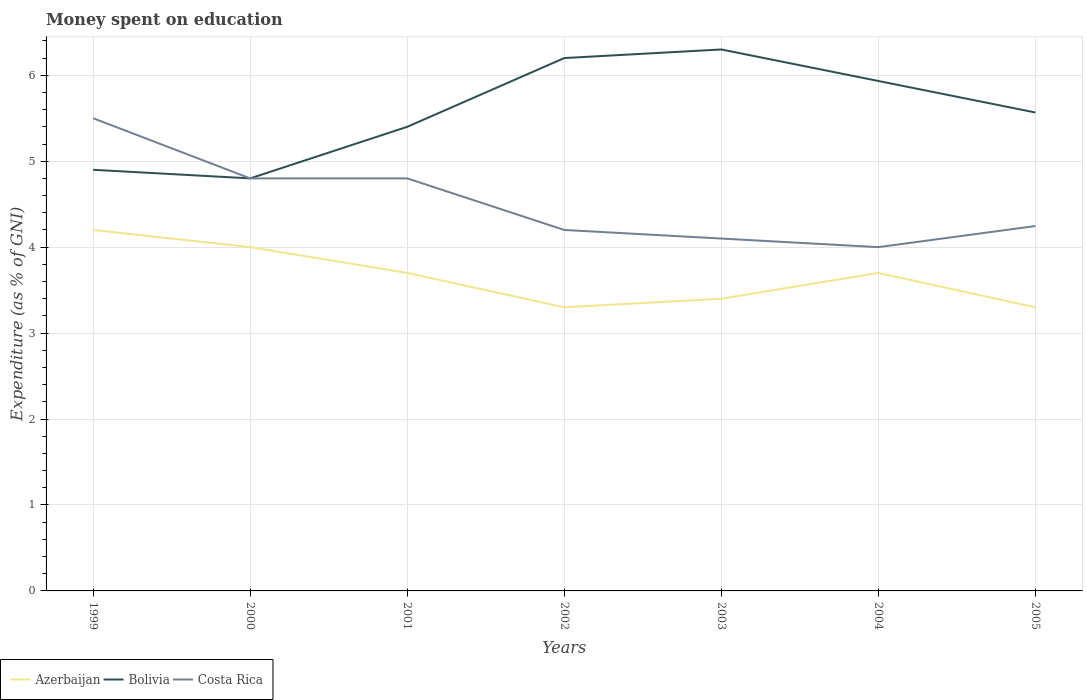How many different coloured lines are there?
Your answer should be very brief. 3. Across all years, what is the maximum amount of money spent on education in Costa Rica?
Offer a very short reply. 4. In which year was the amount of money spent on education in Azerbaijan maximum?
Offer a terse response. 2002. What is the total amount of money spent on education in Bolivia in the graph?
Your answer should be compact. 0.37. What is the difference between the highest and the second highest amount of money spent on education in Azerbaijan?
Make the answer very short. 0.9. Is the amount of money spent on education in Bolivia strictly greater than the amount of money spent on education in Azerbaijan over the years?
Ensure brevity in your answer.  No. How many lines are there?
Your response must be concise. 3. Are the values on the major ticks of Y-axis written in scientific E-notation?
Provide a short and direct response. No. How many legend labels are there?
Provide a succinct answer. 3. How are the legend labels stacked?
Ensure brevity in your answer.  Horizontal. What is the title of the graph?
Keep it short and to the point. Money spent on education. Does "Venezuela" appear as one of the legend labels in the graph?
Offer a terse response. No. What is the label or title of the Y-axis?
Offer a terse response. Expenditure (as % of GNI). What is the Expenditure (as % of GNI) in Azerbaijan in 1999?
Ensure brevity in your answer.  4.2. What is the Expenditure (as % of GNI) in Bolivia in 1999?
Give a very brief answer. 4.9. What is the Expenditure (as % of GNI) of Costa Rica in 1999?
Offer a terse response. 5.5. What is the Expenditure (as % of GNI) in Azerbaijan in 2000?
Your answer should be very brief. 4. What is the Expenditure (as % of GNI) in Bolivia in 2000?
Offer a terse response. 4.8. What is the Expenditure (as % of GNI) in Azerbaijan in 2001?
Your answer should be compact. 3.7. What is the Expenditure (as % of GNI) in Costa Rica in 2001?
Your answer should be compact. 4.8. What is the Expenditure (as % of GNI) in Azerbaijan in 2002?
Provide a short and direct response. 3.3. What is the Expenditure (as % of GNI) of Bolivia in 2002?
Make the answer very short. 6.2. What is the Expenditure (as % of GNI) of Costa Rica in 2002?
Your answer should be very brief. 4.2. What is the Expenditure (as % of GNI) of Bolivia in 2003?
Keep it short and to the point. 6.3. What is the Expenditure (as % of GNI) of Costa Rica in 2003?
Provide a short and direct response. 4.1. What is the Expenditure (as % of GNI) of Bolivia in 2004?
Your answer should be very brief. 5.93. What is the Expenditure (as % of GNI) of Costa Rica in 2004?
Ensure brevity in your answer.  4. What is the Expenditure (as % of GNI) of Azerbaijan in 2005?
Provide a short and direct response. 3.3. What is the Expenditure (as % of GNI) of Bolivia in 2005?
Ensure brevity in your answer.  5.57. What is the Expenditure (as % of GNI) of Costa Rica in 2005?
Ensure brevity in your answer.  4.25. Across all years, what is the minimum Expenditure (as % of GNI) of Bolivia?
Offer a very short reply. 4.8. What is the total Expenditure (as % of GNI) of Azerbaijan in the graph?
Keep it short and to the point. 25.6. What is the total Expenditure (as % of GNI) of Bolivia in the graph?
Ensure brevity in your answer.  39.1. What is the total Expenditure (as % of GNI) in Costa Rica in the graph?
Keep it short and to the point. 31.65. What is the difference between the Expenditure (as % of GNI) in Azerbaijan in 1999 and that in 2001?
Keep it short and to the point. 0.5. What is the difference between the Expenditure (as % of GNI) in Bolivia in 1999 and that in 2001?
Your answer should be very brief. -0.5. What is the difference between the Expenditure (as % of GNI) in Costa Rica in 1999 and that in 2001?
Give a very brief answer. 0.7. What is the difference between the Expenditure (as % of GNI) in Costa Rica in 1999 and that in 2003?
Provide a short and direct response. 1.4. What is the difference between the Expenditure (as % of GNI) of Bolivia in 1999 and that in 2004?
Ensure brevity in your answer.  -1.03. What is the difference between the Expenditure (as % of GNI) in Azerbaijan in 1999 and that in 2005?
Your answer should be very brief. 0.9. What is the difference between the Expenditure (as % of GNI) in Costa Rica in 1999 and that in 2005?
Offer a terse response. 1.25. What is the difference between the Expenditure (as % of GNI) of Azerbaijan in 2000 and that in 2001?
Your answer should be very brief. 0.3. What is the difference between the Expenditure (as % of GNI) in Bolivia in 2000 and that in 2002?
Make the answer very short. -1.4. What is the difference between the Expenditure (as % of GNI) of Azerbaijan in 2000 and that in 2003?
Your response must be concise. 0.6. What is the difference between the Expenditure (as % of GNI) in Bolivia in 2000 and that in 2003?
Provide a succinct answer. -1.5. What is the difference between the Expenditure (as % of GNI) in Costa Rica in 2000 and that in 2003?
Make the answer very short. 0.7. What is the difference between the Expenditure (as % of GNI) of Azerbaijan in 2000 and that in 2004?
Offer a terse response. 0.3. What is the difference between the Expenditure (as % of GNI) in Bolivia in 2000 and that in 2004?
Offer a terse response. -1.13. What is the difference between the Expenditure (as % of GNI) of Costa Rica in 2000 and that in 2004?
Your answer should be very brief. 0.8. What is the difference between the Expenditure (as % of GNI) in Bolivia in 2000 and that in 2005?
Provide a short and direct response. -0.77. What is the difference between the Expenditure (as % of GNI) in Costa Rica in 2000 and that in 2005?
Your response must be concise. 0.55. What is the difference between the Expenditure (as % of GNI) in Bolivia in 2001 and that in 2002?
Keep it short and to the point. -0.8. What is the difference between the Expenditure (as % of GNI) of Costa Rica in 2001 and that in 2002?
Give a very brief answer. 0.6. What is the difference between the Expenditure (as % of GNI) in Azerbaijan in 2001 and that in 2003?
Give a very brief answer. 0.3. What is the difference between the Expenditure (as % of GNI) in Bolivia in 2001 and that in 2003?
Ensure brevity in your answer.  -0.9. What is the difference between the Expenditure (as % of GNI) in Azerbaijan in 2001 and that in 2004?
Offer a very short reply. 0. What is the difference between the Expenditure (as % of GNI) in Bolivia in 2001 and that in 2004?
Your answer should be compact. -0.53. What is the difference between the Expenditure (as % of GNI) in Costa Rica in 2001 and that in 2004?
Your answer should be compact. 0.8. What is the difference between the Expenditure (as % of GNI) in Bolivia in 2001 and that in 2005?
Provide a short and direct response. -0.17. What is the difference between the Expenditure (as % of GNI) of Costa Rica in 2001 and that in 2005?
Offer a very short reply. 0.55. What is the difference between the Expenditure (as % of GNI) of Bolivia in 2002 and that in 2003?
Provide a succinct answer. -0.1. What is the difference between the Expenditure (as % of GNI) of Azerbaijan in 2002 and that in 2004?
Your answer should be compact. -0.4. What is the difference between the Expenditure (as % of GNI) of Bolivia in 2002 and that in 2004?
Provide a short and direct response. 0.27. What is the difference between the Expenditure (as % of GNI) of Azerbaijan in 2002 and that in 2005?
Ensure brevity in your answer.  0. What is the difference between the Expenditure (as % of GNI) in Bolivia in 2002 and that in 2005?
Your answer should be very brief. 0.63. What is the difference between the Expenditure (as % of GNI) in Costa Rica in 2002 and that in 2005?
Give a very brief answer. -0.05. What is the difference between the Expenditure (as % of GNI) of Azerbaijan in 2003 and that in 2004?
Give a very brief answer. -0.3. What is the difference between the Expenditure (as % of GNI) of Bolivia in 2003 and that in 2004?
Offer a very short reply. 0.37. What is the difference between the Expenditure (as % of GNI) of Bolivia in 2003 and that in 2005?
Make the answer very short. 0.73. What is the difference between the Expenditure (as % of GNI) in Costa Rica in 2003 and that in 2005?
Make the answer very short. -0.15. What is the difference between the Expenditure (as % of GNI) in Azerbaijan in 2004 and that in 2005?
Offer a very short reply. 0.4. What is the difference between the Expenditure (as % of GNI) of Bolivia in 2004 and that in 2005?
Keep it short and to the point. 0.37. What is the difference between the Expenditure (as % of GNI) of Costa Rica in 2004 and that in 2005?
Offer a terse response. -0.25. What is the difference between the Expenditure (as % of GNI) of Azerbaijan in 1999 and the Expenditure (as % of GNI) of Bolivia in 2000?
Give a very brief answer. -0.6. What is the difference between the Expenditure (as % of GNI) in Azerbaijan in 1999 and the Expenditure (as % of GNI) in Costa Rica in 2000?
Your response must be concise. -0.6. What is the difference between the Expenditure (as % of GNI) in Azerbaijan in 1999 and the Expenditure (as % of GNI) in Bolivia in 2003?
Give a very brief answer. -2.1. What is the difference between the Expenditure (as % of GNI) in Azerbaijan in 1999 and the Expenditure (as % of GNI) in Costa Rica in 2003?
Provide a succinct answer. 0.1. What is the difference between the Expenditure (as % of GNI) of Azerbaijan in 1999 and the Expenditure (as % of GNI) of Bolivia in 2004?
Offer a terse response. -1.73. What is the difference between the Expenditure (as % of GNI) in Bolivia in 1999 and the Expenditure (as % of GNI) in Costa Rica in 2004?
Ensure brevity in your answer.  0.9. What is the difference between the Expenditure (as % of GNI) in Azerbaijan in 1999 and the Expenditure (as % of GNI) in Bolivia in 2005?
Offer a terse response. -1.37. What is the difference between the Expenditure (as % of GNI) in Azerbaijan in 1999 and the Expenditure (as % of GNI) in Costa Rica in 2005?
Make the answer very short. -0.05. What is the difference between the Expenditure (as % of GNI) of Bolivia in 1999 and the Expenditure (as % of GNI) of Costa Rica in 2005?
Your answer should be very brief. 0.65. What is the difference between the Expenditure (as % of GNI) of Bolivia in 2000 and the Expenditure (as % of GNI) of Costa Rica in 2001?
Provide a succinct answer. 0. What is the difference between the Expenditure (as % of GNI) of Azerbaijan in 2000 and the Expenditure (as % of GNI) of Costa Rica in 2002?
Your response must be concise. -0.2. What is the difference between the Expenditure (as % of GNI) of Bolivia in 2000 and the Expenditure (as % of GNI) of Costa Rica in 2002?
Ensure brevity in your answer.  0.6. What is the difference between the Expenditure (as % of GNI) of Azerbaijan in 2000 and the Expenditure (as % of GNI) of Costa Rica in 2003?
Keep it short and to the point. -0.1. What is the difference between the Expenditure (as % of GNI) in Bolivia in 2000 and the Expenditure (as % of GNI) in Costa Rica in 2003?
Offer a very short reply. 0.7. What is the difference between the Expenditure (as % of GNI) in Azerbaijan in 2000 and the Expenditure (as % of GNI) in Bolivia in 2004?
Provide a short and direct response. -1.93. What is the difference between the Expenditure (as % of GNI) in Azerbaijan in 2000 and the Expenditure (as % of GNI) in Costa Rica in 2004?
Make the answer very short. 0. What is the difference between the Expenditure (as % of GNI) in Azerbaijan in 2000 and the Expenditure (as % of GNI) in Bolivia in 2005?
Give a very brief answer. -1.57. What is the difference between the Expenditure (as % of GNI) in Azerbaijan in 2000 and the Expenditure (as % of GNI) in Costa Rica in 2005?
Your response must be concise. -0.25. What is the difference between the Expenditure (as % of GNI) of Bolivia in 2000 and the Expenditure (as % of GNI) of Costa Rica in 2005?
Keep it short and to the point. 0.55. What is the difference between the Expenditure (as % of GNI) of Azerbaijan in 2001 and the Expenditure (as % of GNI) of Bolivia in 2002?
Your answer should be compact. -2.5. What is the difference between the Expenditure (as % of GNI) of Azerbaijan in 2001 and the Expenditure (as % of GNI) of Bolivia in 2004?
Give a very brief answer. -2.23. What is the difference between the Expenditure (as % of GNI) in Bolivia in 2001 and the Expenditure (as % of GNI) in Costa Rica in 2004?
Provide a succinct answer. 1.4. What is the difference between the Expenditure (as % of GNI) in Azerbaijan in 2001 and the Expenditure (as % of GNI) in Bolivia in 2005?
Make the answer very short. -1.87. What is the difference between the Expenditure (as % of GNI) in Azerbaijan in 2001 and the Expenditure (as % of GNI) in Costa Rica in 2005?
Offer a very short reply. -0.55. What is the difference between the Expenditure (as % of GNI) of Bolivia in 2001 and the Expenditure (as % of GNI) of Costa Rica in 2005?
Provide a succinct answer. 1.15. What is the difference between the Expenditure (as % of GNI) of Azerbaijan in 2002 and the Expenditure (as % of GNI) of Costa Rica in 2003?
Offer a terse response. -0.8. What is the difference between the Expenditure (as % of GNI) of Bolivia in 2002 and the Expenditure (as % of GNI) of Costa Rica in 2003?
Offer a terse response. 2.1. What is the difference between the Expenditure (as % of GNI) of Azerbaijan in 2002 and the Expenditure (as % of GNI) of Bolivia in 2004?
Make the answer very short. -2.63. What is the difference between the Expenditure (as % of GNI) of Azerbaijan in 2002 and the Expenditure (as % of GNI) of Costa Rica in 2004?
Your response must be concise. -0.7. What is the difference between the Expenditure (as % of GNI) of Azerbaijan in 2002 and the Expenditure (as % of GNI) of Bolivia in 2005?
Provide a succinct answer. -2.27. What is the difference between the Expenditure (as % of GNI) of Azerbaijan in 2002 and the Expenditure (as % of GNI) of Costa Rica in 2005?
Offer a terse response. -0.95. What is the difference between the Expenditure (as % of GNI) of Bolivia in 2002 and the Expenditure (as % of GNI) of Costa Rica in 2005?
Offer a very short reply. 1.95. What is the difference between the Expenditure (as % of GNI) in Azerbaijan in 2003 and the Expenditure (as % of GNI) in Bolivia in 2004?
Provide a succinct answer. -2.53. What is the difference between the Expenditure (as % of GNI) in Bolivia in 2003 and the Expenditure (as % of GNI) in Costa Rica in 2004?
Keep it short and to the point. 2.3. What is the difference between the Expenditure (as % of GNI) in Azerbaijan in 2003 and the Expenditure (as % of GNI) in Bolivia in 2005?
Offer a very short reply. -2.17. What is the difference between the Expenditure (as % of GNI) of Azerbaijan in 2003 and the Expenditure (as % of GNI) of Costa Rica in 2005?
Provide a short and direct response. -0.85. What is the difference between the Expenditure (as % of GNI) in Bolivia in 2003 and the Expenditure (as % of GNI) in Costa Rica in 2005?
Keep it short and to the point. 2.05. What is the difference between the Expenditure (as % of GNI) of Azerbaijan in 2004 and the Expenditure (as % of GNI) of Bolivia in 2005?
Provide a succinct answer. -1.87. What is the difference between the Expenditure (as % of GNI) in Azerbaijan in 2004 and the Expenditure (as % of GNI) in Costa Rica in 2005?
Keep it short and to the point. -0.55. What is the difference between the Expenditure (as % of GNI) of Bolivia in 2004 and the Expenditure (as % of GNI) of Costa Rica in 2005?
Offer a very short reply. 1.69. What is the average Expenditure (as % of GNI) of Azerbaijan per year?
Your answer should be compact. 3.66. What is the average Expenditure (as % of GNI) of Bolivia per year?
Ensure brevity in your answer.  5.59. What is the average Expenditure (as % of GNI) of Costa Rica per year?
Offer a terse response. 4.52. In the year 1999, what is the difference between the Expenditure (as % of GNI) in Bolivia and Expenditure (as % of GNI) in Costa Rica?
Your answer should be compact. -0.6. In the year 2000, what is the difference between the Expenditure (as % of GNI) in Azerbaijan and Expenditure (as % of GNI) in Bolivia?
Provide a succinct answer. -0.8. In the year 2001, what is the difference between the Expenditure (as % of GNI) of Azerbaijan and Expenditure (as % of GNI) of Costa Rica?
Provide a short and direct response. -1.1. In the year 2001, what is the difference between the Expenditure (as % of GNI) in Bolivia and Expenditure (as % of GNI) in Costa Rica?
Your response must be concise. 0.6. In the year 2002, what is the difference between the Expenditure (as % of GNI) in Azerbaijan and Expenditure (as % of GNI) in Bolivia?
Offer a terse response. -2.9. In the year 2002, what is the difference between the Expenditure (as % of GNI) of Azerbaijan and Expenditure (as % of GNI) of Costa Rica?
Provide a succinct answer. -0.9. In the year 2002, what is the difference between the Expenditure (as % of GNI) of Bolivia and Expenditure (as % of GNI) of Costa Rica?
Offer a terse response. 2. In the year 2003, what is the difference between the Expenditure (as % of GNI) of Bolivia and Expenditure (as % of GNI) of Costa Rica?
Give a very brief answer. 2.2. In the year 2004, what is the difference between the Expenditure (as % of GNI) of Azerbaijan and Expenditure (as % of GNI) of Bolivia?
Make the answer very short. -2.23. In the year 2004, what is the difference between the Expenditure (as % of GNI) of Bolivia and Expenditure (as % of GNI) of Costa Rica?
Your answer should be very brief. 1.93. In the year 2005, what is the difference between the Expenditure (as % of GNI) in Azerbaijan and Expenditure (as % of GNI) in Bolivia?
Your answer should be very brief. -2.27. In the year 2005, what is the difference between the Expenditure (as % of GNI) in Azerbaijan and Expenditure (as % of GNI) in Costa Rica?
Offer a terse response. -0.95. In the year 2005, what is the difference between the Expenditure (as % of GNI) of Bolivia and Expenditure (as % of GNI) of Costa Rica?
Make the answer very short. 1.32. What is the ratio of the Expenditure (as % of GNI) in Azerbaijan in 1999 to that in 2000?
Provide a succinct answer. 1.05. What is the ratio of the Expenditure (as % of GNI) in Bolivia in 1999 to that in 2000?
Keep it short and to the point. 1.02. What is the ratio of the Expenditure (as % of GNI) in Costa Rica in 1999 to that in 2000?
Give a very brief answer. 1.15. What is the ratio of the Expenditure (as % of GNI) in Azerbaijan in 1999 to that in 2001?
Offer a terse response. 1.14. What is the ratio of the Expenditure (as % of GNI) of Bolivia in 1999 to that in 2001?
Your response must be concise. 0.91. What is the ratio of the Expenditure (as % of GNI) of Costa Rica in 1999 to that in 2001?
Provide a succinct answer. 1.15. What is the ratio of the Expenditure (as % of GNI) of Azerbaijan in 1999 to that in 2002?
Your response must be concise. 1.27. What is the ratio of the Expenditure (as % of GNI) of Bolivia in 1999 to that in 2002?
Provide a short and direct response. 0.79. What is the ratio of the Expenditure (as % of GNI) in Costa Rica in 1999 to that in 2002?
Offer a terse response. 1.31. What is the ratio of the Expenditure (as % of GNI) of Azerbaijan in 1999 to that in 2003?
Make the answer very short. 1.24. What is the ratio of the Expenditure (as % of GNI) in Bolivia in 1999 to that in 2003?
Your answer should be compact. 0.78. What is the ratio of the Expenditure (as % of GNI) in Costa Rica in 1999 to that in 2003?
Make the answer very short. 1.34. What is the ratio of the Expenditure (as % of GNI) in Azerbaijan in 1999 to that in 2004?
Keep it short and to the point. 1.14. What is the ratio of the Expenditure (as % of GNI) in Bolivia in 1999 to that in 2004?
Your answer should be compact. 0.83. What is the ratio of the Expenditure (as % of GNI) in Costa Rica in 1999 to that in 2004?
Your answer should be compact. 1.38. What is the ratio of the Expenditure (as % of GNI) in Azerbaijan in 1999 to that in 2005?
Offer a very short reply. 1.27. What is the ratio of the Expenditure (as % of GNI) in Bolivia in 1999 to that in 2005?
Give a very brief answer. 0.88. What is the ratio of the Expenditure (as % of GNI) of Costa Rica in 1999 to that in 2005?
Give a very brief answer. 1.3. What is the ratio of the Expenditure (as % of GNI) of Azerbaijan in 2000 to that in 2001?
Make the answer very short. 1.08. What is the ratio of the Expenditure (as % of GNI) in Azerbaijan in 2000 to that in 2002?
Your answer should be compact. 1.21. What is the ratio of the Expenditure (as % of GNI) of Bolivia in 2000 to that in 2002?
Give a very brief answer. 0.77. What is the ratio of the Expenditure (as % of GNI) in Costa Rica in 2000 to that in 2002?
Your answer should be compact. 1.14. What is the ratio of the Expenditure (as % of GNI) of Azerbaijan in 2000 to that in 2003?
Provide a short and direct response. 1.18. What is the ratio of the Expenditure (as % of GNI) of Bolivia in 2000 to that in 2003?
Make the answer very short. 0.76. What is the ratio of the Expenditure (as % of GNI) in Costa Rica in 2000 to that in 2003?
Your answer should be compact. 1.17. What is the ratio of the Expenditure (as % of GNI) in Azerbaijan in 2000 to that in 2004?
Your answer should be compact. 1.08. What is the ratio of the Expenditure (as % of GNI) in Bolivia in 2000 to that in 2004?
Ensure brevity in your answer.  0.81. What is the ratio of the Expenditure (as % of GNI) of Azerbaijan in 2000 to that in 2005?
Provide a short and direct response. 1.21. What is the ratio of the Expenditure (as % of GNI) of Bolivia in 2000 to that in 2005?
Your answer should be very brief. 0.86. What is the ratio of the Expenditure (as % of GNI) in Costa Rica in 2000 to that in 2005?
Offer a very short reply. 1.13. What is the ratio of the Expenditure (as % of GNI) of Azerbaijan in 2001 to that in 2002?
Make the answer very short. 1.12. What is the ratio of the Expenditure (as % of GNI) in Bolivia in 2001 to that in 2002?
Your answer should be compact. 0.87. What is the ratio of the Expenditure (as % of GNI) of Costa Rica in 2001 to that in 2002?
Provide a succinct answer. 1.14. What is the ratio of the Expenditure (as % of GNI) in Azerbaijan in 2001 to that in 2003?
Your answer should be compact. 1.09. What is the ratio of the Expenditure (as % of GNI) in Bolivia in 2001 to that in 2003?
Offer a terse response. 0.86. What is the ratio of the Expenditure (as % of GNI) in Costa Rica in 2001 to that in 2003?
Offer a very short reply. 1.17. What is the ratio of the Expenditure (as % of GNI) in Bolivia in 2001 to that in 2004?
Ensure brevity in your answer.  0.91. What is the ratio of the Expenditure (as % of GNI) of Azerbaijan in 2001 to that in 2005?
Your response must be concise. 1.12. What is the ratio of the Expenditure (as % of GNI) in Bolivia in 2001 to that in 2005?
Make the answer very short. 0.97. What is the ratio of the Expenditure (as % of GNI) of Costa Rica in 2001 to that in 2005?
Provide a succinct answer. 1.13. What is the ratio of the Expenditure (as % of GNI) of Azerbaijan in 2002 to that in 2003?
Give a very brief answer. 0.97. What is the ratio of the Expenditure (as % of GNI) of Bolivia in 2002 to that in 2003?
Keep it short and to the point. 0.98. What is the ratio of the Expenditure (as % of GNI) in Costa Rica in 2002 to that in 2003?
Offer a terse response. 1.02. What is the ratio of the Expenditure (as % of GNI) of Azerbaijan in 2002 to that in 2004?
Provide a succinct answer. 0.89. What is the ratio of the Expenditure (as % of GNI) in Bolivia in 2002 to that in 2004?
Offer a very short reply. 1.04. What is the ratio of the Expenditure (as % of GNI) of Azerbaijan in 2002 to that in 2005?
Offer a terse response. 1. What is the ratio of the Expenditure (as % of GNI) of Bolivia in 2002 to that in 2005?
Ensure brevity in your answer.  1.11. What is the ratio of the Expenditure (as % of GNI) of Costa Rica in 2002 to that in 2005?
Give a very brief answer. 0.99. What is the ratio of the Expenditure (as % of GNI) of Azerbaijan in 2003 to that in 2004?
Provide a succinct answer. 0.92. What is the ratio of the Expenditure (as % of GNI) in Bolivia in 2003 to that in 2004?
Give a very brief answer. 1.06. What is the ratio of the Expenditure (as % of GNI) in Costa Rica in 2003 to that in 2004?
Keep it short and to the point. 1.02. What is the ratio of the Expenditure (as % of GNI) of Azerbaijan in 2003 to that in 2005?
Your answer should be compact. 1.03. What is the ratio of the Expenditure (as % of GNI) of Bolivia in 2003 to that in 2005?
Keep it short and to the point. 1.13. What is the ratio of the Expenditure (as % of GNI) in Costa Rica in 2003 to that in 2005?
Provide a short and direct response. 0.97. What is the ratio of the Expenditure (as % of GNI) in Azerbaijan in 2004 to that in 2005?
Your answer should be compact. 1.12. What is the ratio of the Expenditure (as % of GNI) in Bolivia in 2004 to that in 2005?
Make the answer very short. 1.07. What is the ratio of the Expenditure (as % of GNI) of Costa Rica in 2004 to that in 2005?
Your answer should be very brief. 0.94. What is the difference between the highest and the second highest Expenditure (as % of GNI) of Azerbaijan?
Ensure brevity in your answer.  0.2. What is the difference between the highest and the second highest Expenditure (as % of GNI) of Bolivia?
Your answer should be compact. 0.1. What is the difference between the highest and the lowest Expenditure (as % of GNI) of Azerbaijan?
Your answer should be compact. 0.9. What is the difference between the highest and the lowest Expenditure (as % of GNI) in Bolivia?
Your answer should be compact. 1.5. What is the difference between the highest and the lowest Expenditure (as % of GNI) of Costa Rica?
Ensure brevity in your answer.  1.5. 